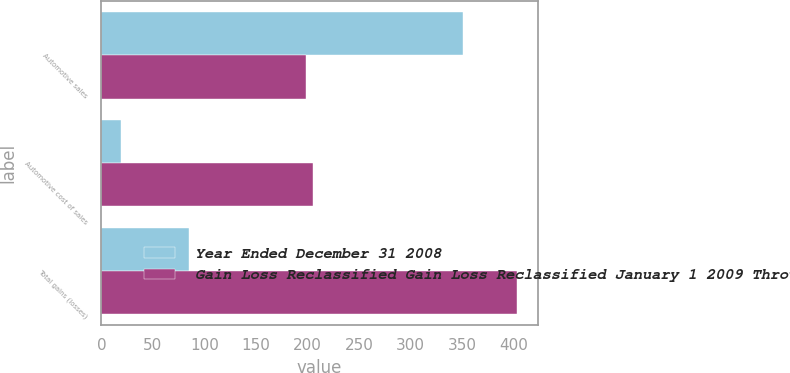Convert chart. <chart><loc_0><loc_0><loc_500><loc_500><stacked_bar_chart><ecel><fcel>Automotive sales<fcel>Automotive cost of sales<fcel>Total gains (losses)<nl><fcel>Year Ended December 31 2008<fcel>351<fcel>19<fcel>85<nl><fcel>Gain Loss Reclassified Gain Loss Reclassified January 1 2009 Through July 9 2009<fcel>198<fcel>205<fcel>403<nl></chart> 